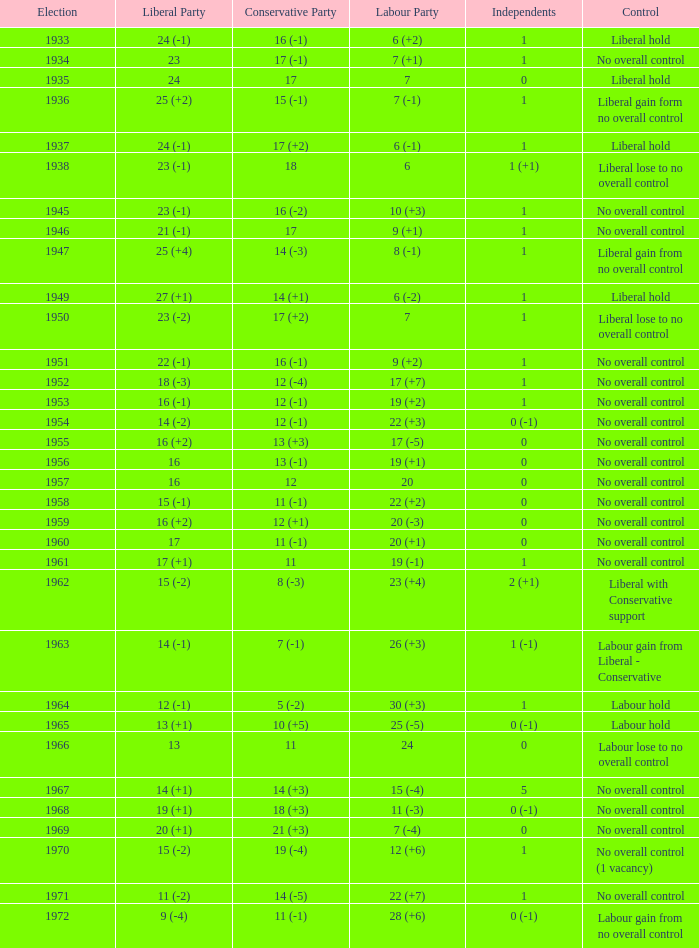What was the liberal party outcome in the election with a conservative party outcome of 16 (-1) and labour of 6 (+2)? 24 (-1). 